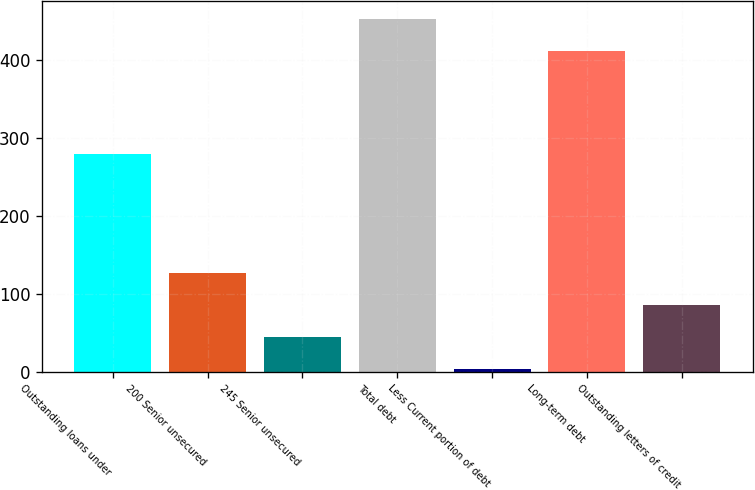Convert chart. <chart><loc_0><loc_0><loc_500><loc_500><bar_chart><fcel>Outstanding loans under<fcel>200 Senior unsecured<fcel>245 Senior unsecured<fcel>Total debt<fcel>Less Current portion of debt<fcel>Long-term debt<fcel>Outstanding letters of credit<nl><fcel>280<fcel>126.6<fcel>44.2<fcel>453.2<fcel>3<fcel>412<fcel>85.4<nl></chart> 